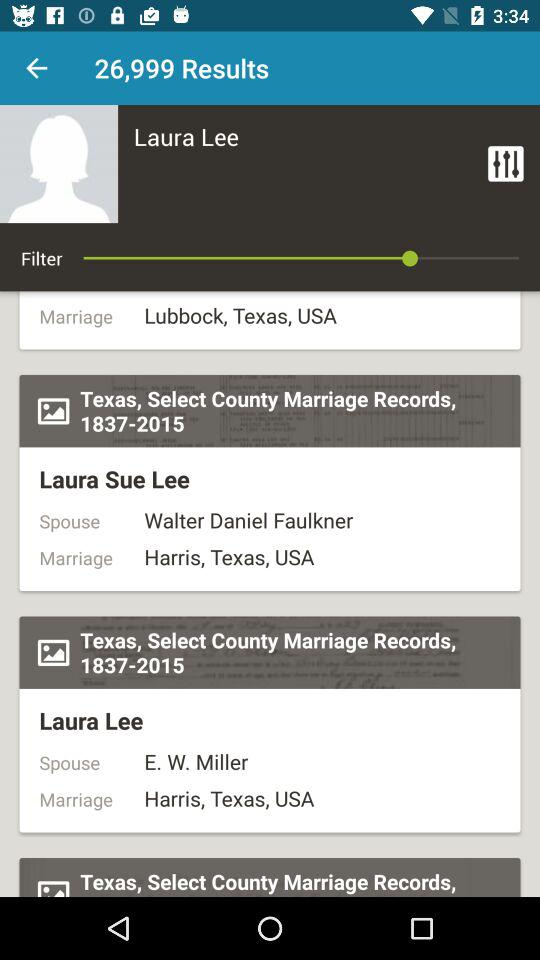What is the location of the marriage of Laura Sue Lee? The location is Lubbock, Texas, USA. 